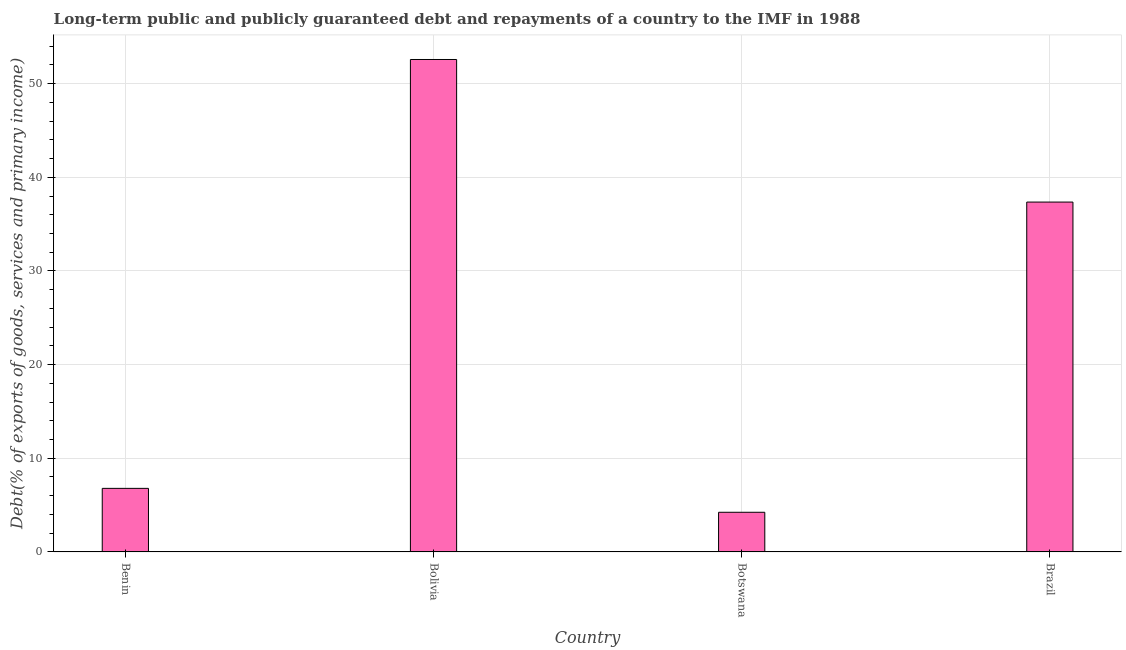Does the graph contain grids?
Provide a short and direct response. Yes. What is the title of the graph?
Make the answer very short. Long-term public and publicly guaranteed debt and repayments of a country to the IMF in 1988. What is the label or title of the X-axis?
Your answer should be very brief. Country. What is the label or title of the Y-axis?
Ensure brevity in your answer.  Debt(% of exports of goods, services and primary income). What is the debt service in Botswana?
Your response must be concise. 4.23. Across all countries, what is the maximum debt service?
Your answer should be compact. 52.58. Across all countries, what is the minimum debt service?
Offer a terse response. 4.23. In which country was the debt service minimum?
Provide a succinct answer. Botswana. What is the sum of the debt service?
Keep it short and to the point. 100.95. What is the difference between the debt service in Bolivia and Brazil?
Your answer should be compact. 15.22. What is the average debt service per country?
Your answer should be very brief. 25.24. What is the median debt service?
Offer a terse response. 22.07. What is the ratio of the debt service in Benin to that in Bolivia?
Give a very brief answer. 0.13. Is the debt service in Bolivia less than that in Brazil?
Your response must be concise. No. What is the difference between the highest and the second highest debt service?
Ensure brevity in your answer.  15.22. Is the sum of the debt service in Benin and Brazil greater than the maximum debt service across all countries?
Keep it short and to the point. No. What is the difference between the highest and the lowest debt service?
Offer a terse response. 48.35. How many countries are there in the graph?
Your response must be concise. 4. What is the Debt(% of exports of goods, services and primary income) in Benin?
Offer a terse response. 6.78. What is the Debt(% of exports of goods, services and primary income) of Bolivia?
Provide a succinct answer. 52.58. What is the Debt(% of exports of goods, services and primary income) in Botswana?
Keep it short and to the point. 4.23. What is the Debt(% of exports of goods, services and primary income) in Brazil?
Offer a very short reply. 37.36. What is the difference between the Debt(% of exports of goods, services and primary income) in Benin and Bolivia?
Provide a short and direct response. -45.79. What is the difference between the Debt(% of exports of goods, services and primary income) in Benin and Botswana?
Your answer should be compact. 2.55. What is the difference between the Debt(% of exports of goods, services and primary income) in Benin and Brazil?
Provide a short and direct response. -30.57. What is the difference between the Debt(% of exports of goods, services and primary income) in Bolivia and Botswana?
Offer a terse response. 48.35. What is the difference between the Debt(% of exports of goods, services and primary income) in Bolivia and Brazil?
Provide a short and direct response. 15.22. What is the difference between the Debt(% of exports of goods, services and primary income) in Botswana and Brazil?
Provide a short and direct response. -33.12. What is the ratio of the Debt(% of exports of goods, services and primary income) in Benin to that in Bolivia?
Your response must be concise. 0.13. What is the ratio of the Debt(% of exports of goods, services and primary income) in Benin to that in Botswana?
Offer a very short reply. 1.6. What is the ratio of the Debt(% of exports of goods, services and primary income) in Benin to that in Brazil?
Your response must be concise. 0.18. What is the ratio of the Debt(% of exports of goods, services and primary income) in Bolivia to that in Botswana?
Provide a succinct answer. 12.42. What is the ratio of the Debt(% of exports of goods, services and primary income) in Bolivia to that in Brazil?
Provide a succinct answer. 1.41. What is the ratio of the Debt(% of exports of goods, services and primary income) in Botswana to that in Brazil?
Keep it short and to the point. 0.11. 